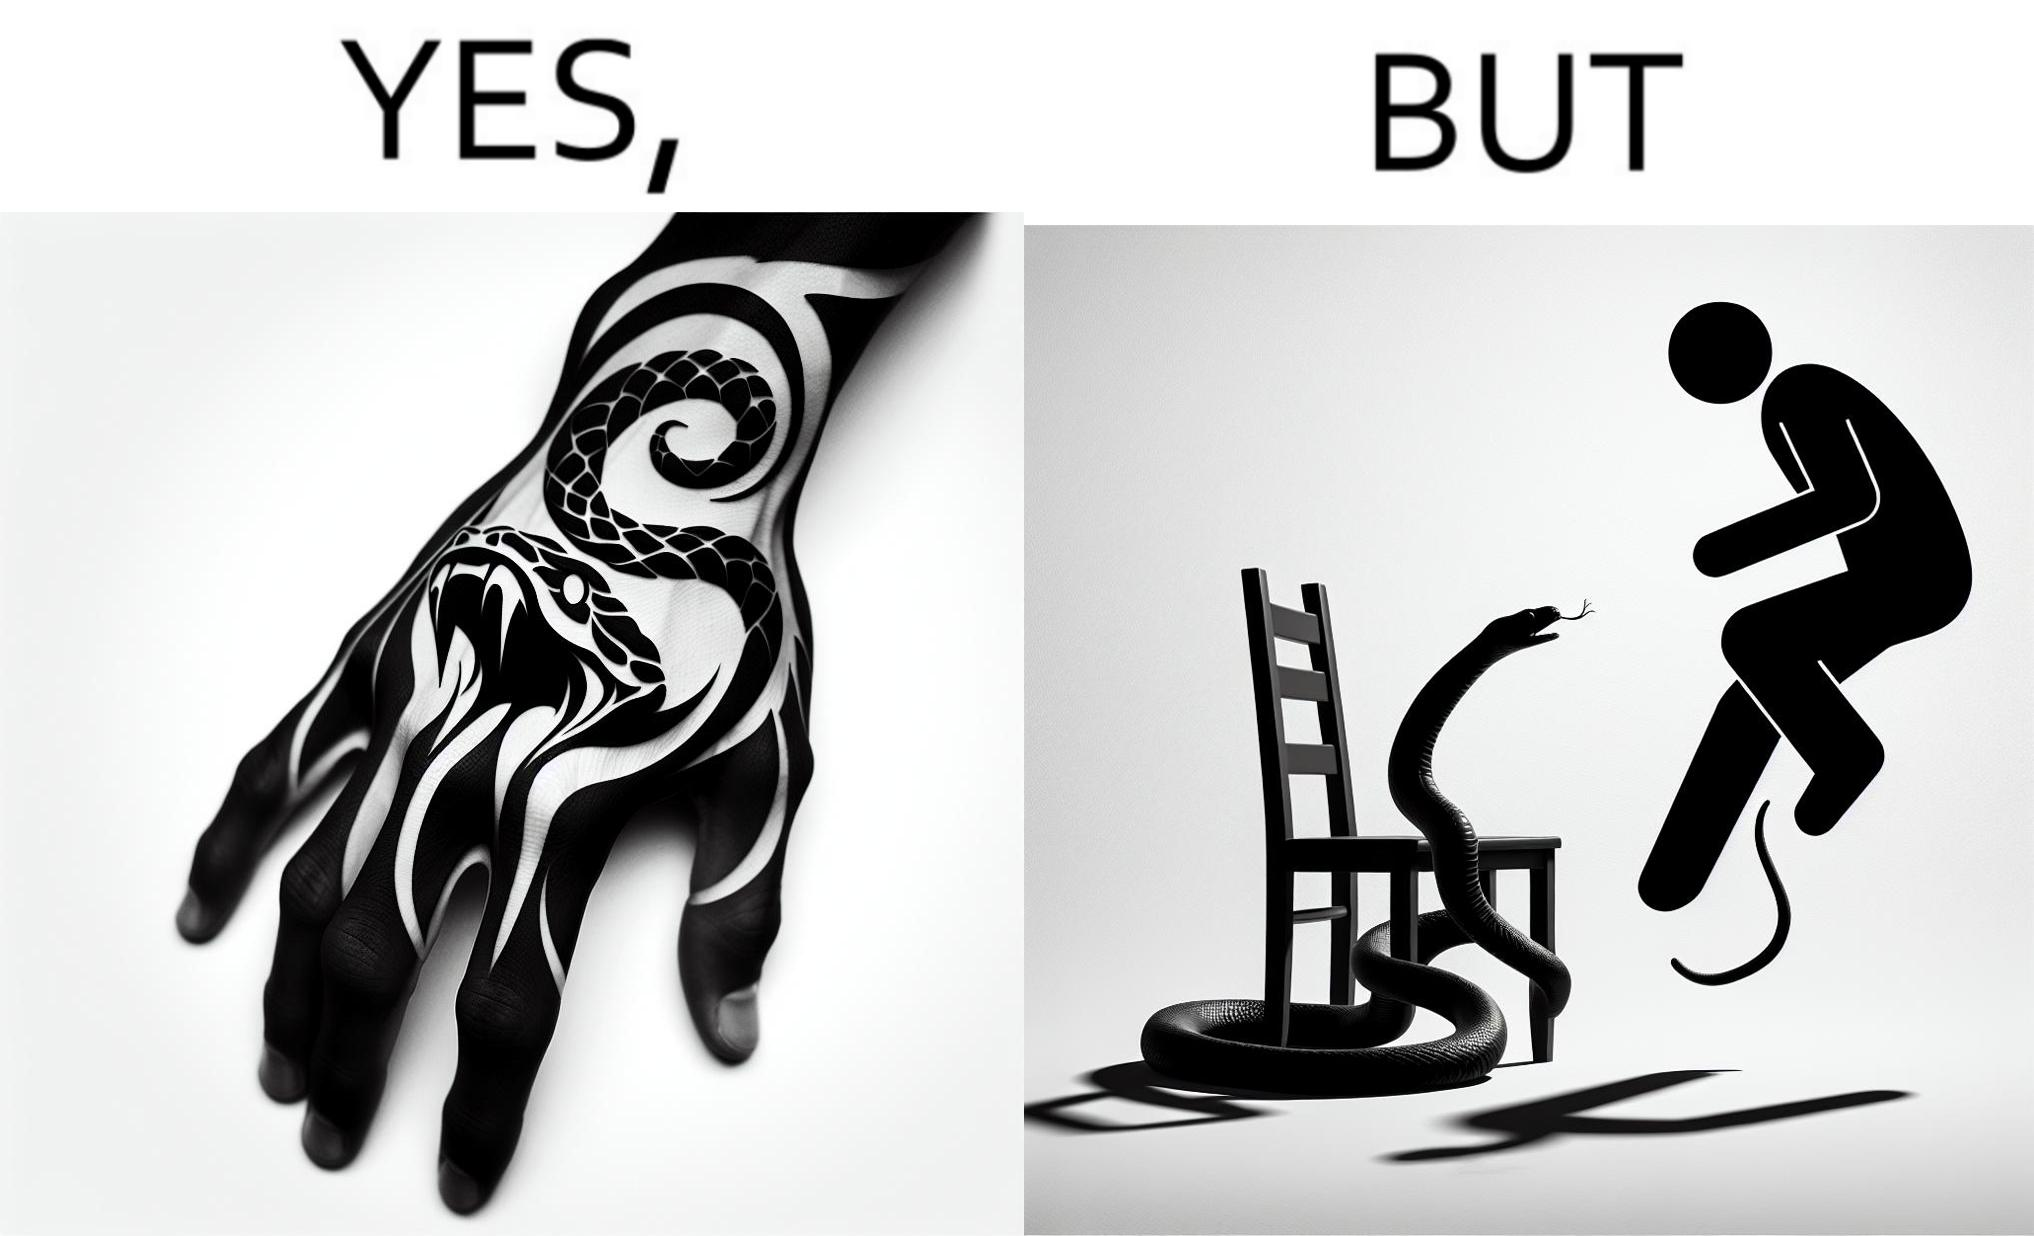Does this image contain satire or humor? Yes, this image is satirical. 